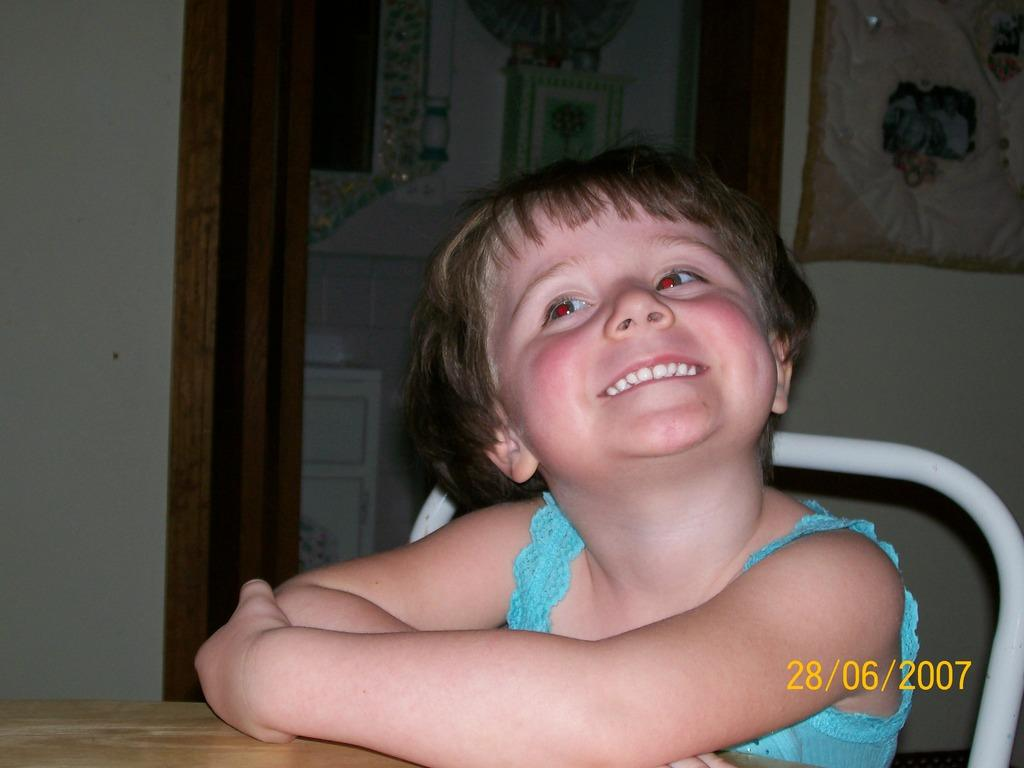What is the main subject of the image? The main subject of the image is a kid. What is the kid doing in the image? The kid is sitting on a chair and smiling. What can be seen in the background of the image? There is a white wall in the image. Is there any text or information displayed in the image? Yes, the date is displayed in numbers in the image. Can you tell me how many snakes are slithering on the canvas in the image? There are no snakes or canvas present in the image; it features a kid sitting on a chair and smiling. 